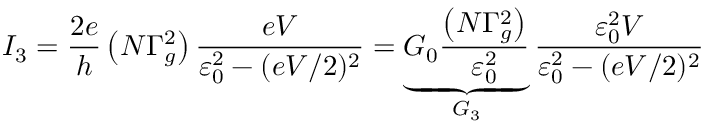<formula> <loc_0><loc_0><loc_500><loc_500>I _ { 3 } = \frac { 2 e } { h } \left ( N \Gamma _ { g } ^ { 2 } \right ) \frac { e V } { \varepsilon _ { 0 } ^ { 2 } - ( e V / 2 ) ^ { 2 } } = \underbrace { G _ { 0 } \frac { \left ( N \Gamma _ { g } ^ { 2 } \right ) } { \varepsilon _ { 0 } ^ { 2 } } } _ { G _ { 3 } } \frac { \varepsilon _ { 0 } ^ { 2 } V } { \varepsilon _ { 0 } ^ { 2 } - ( e V / 2 ) ^ { 2 } }</formula> 